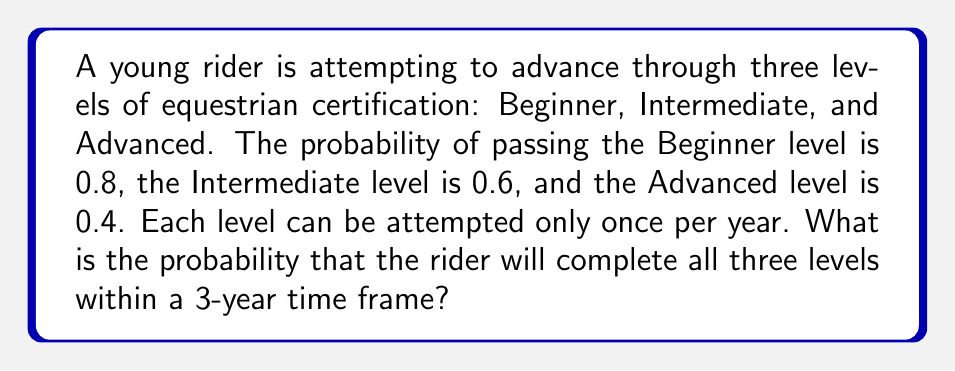Give your solution to this math problem. Let's approach this step-by-step:

1) To complete all three levels within 3 years, the rider must pass each level in succession without failing any level.

2) The probability of passing all three levels in exactly three years is:
   $$P(\text{All 3 in 3 years}) = 0.8 \times 0.6 \times 0.4 = 0.192$$

3) However, the rider could also complete the levels in fewer than 3 years. Let's calculate these probabilities:

   a) Completing in 1 year: 
      $$P(\text{All 3 in 1 year}) = 0.8 \times 0.6 \times 0.4 = 0.192$$

   b) Completing in 2 years:
      $$P(\text{2 in 1st year, 1 in 2nd}) = (0.8 \times 0.6) \times 0.4 = 0.192$$

4) The total probability is the sum of these mutually exclusive events:
   $$P(\text{All 3 within 3 years}) = P(\text{1 year}) + P(\text{2 years}) + P(\text{3 years})$$
   $$= 0.192 + 0.192 + 0.192 = 0.576$$

5) Therefore, the probability of completing all three levels within 3 years is 0.576 or 57.6%.
Answer: 0.576 